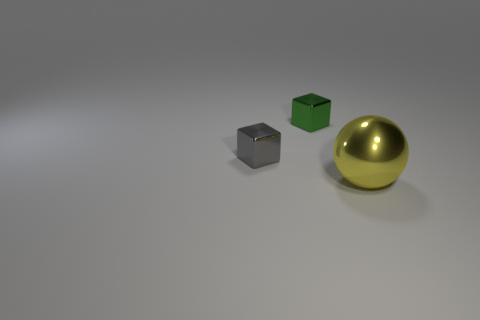Add 2 tiny cubes. How many objects exist? 5 Subtract all cubes. How many objects are left? 1 Subtract 0 purple cylinders. How many objects are left? 3 Subtract all tiny gray metallic blocks. Subtract all large balls. How many objects are left? 1 Add 2 big spheres. How many big spheres are left? 3 Add 3 yellow metal objects. How many yellow metal objects exist? 4 